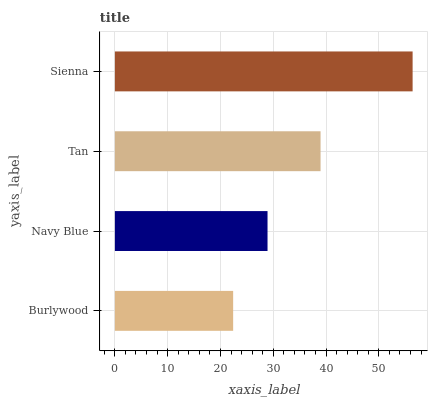Is Burlywood the minimum?
Answer yes or no. Yes. Is Sienna the maximum?
Answer yes or no. Yes. Is Navy Blue the minimum?
Answer yes or no. No. Is Navy Blue the maximum?
Answer yes or no. No. Is Navy Blue greater than Burlywood?
Answer yes or no. Yes. Is Burlywood less than Navy Blue?
Answer yes or no. Yes. Is Burlywood greater than Navy Blue?
Answer yes or no. No. Is Navy Blue less than Burlywood?
Answer yes or no. No. Is Tan the high median?
Answer yes or no. Yes. Is Navy Blue the low median?
Answer yes or no. Yes. Is Burlywood the high median?
Answer yes or no. No. Is Tan the low median?
Answer yes or no. No. 